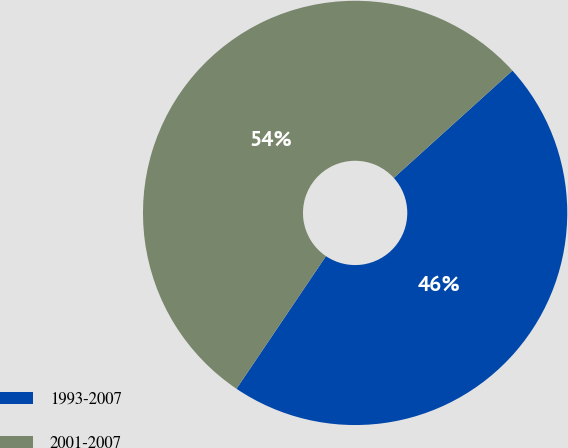<chart> <loc_0><loc_0><loc_500><loc_500><pie_chart><fcel>1993-2007<fcel>2001-2007<nl><fcel>46.15%<fcel>53.85%<nl></chart> 